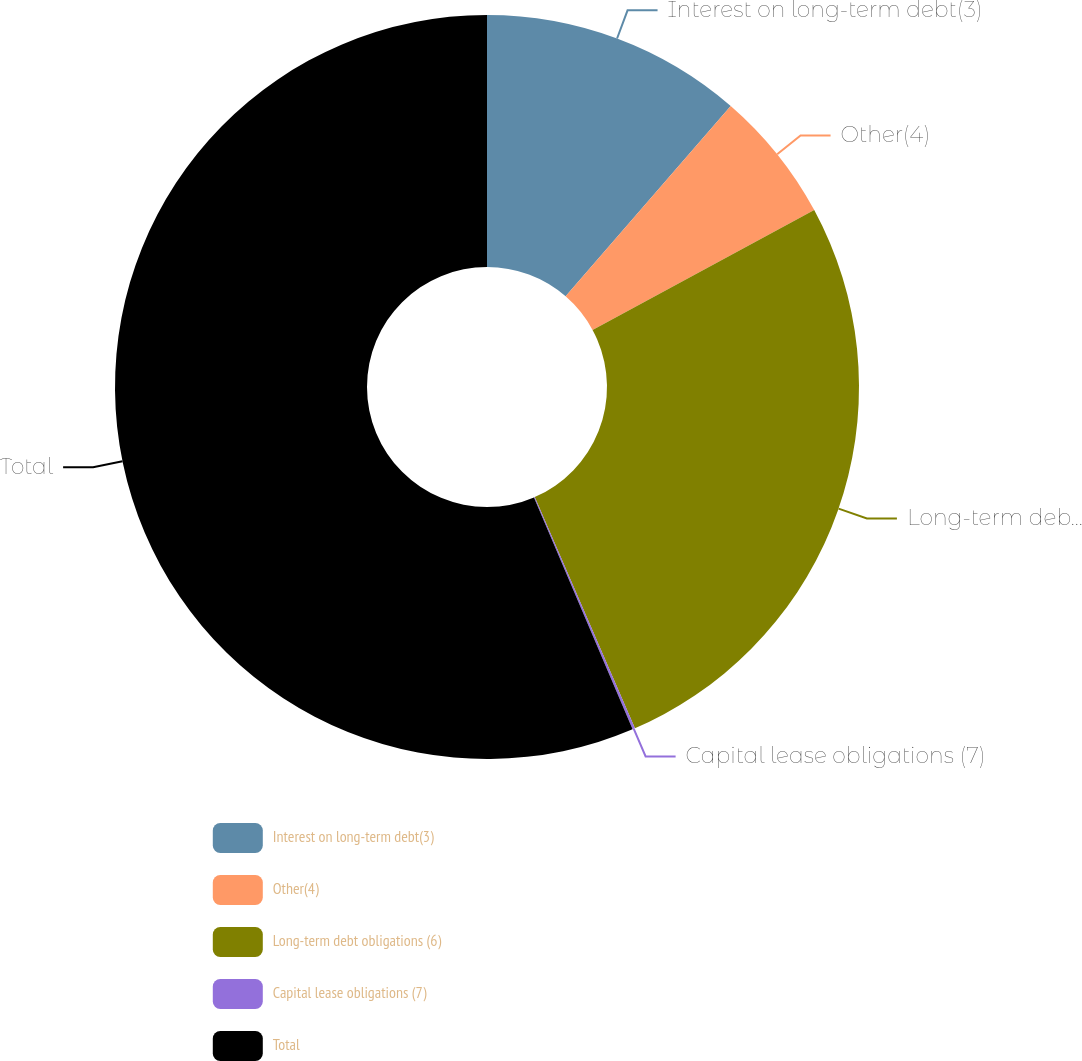<chart> <loc_0><loc_0><loc_500><loc_500><pie_chart><fcel>Interest on long-term debt(3)<fcel>Other(4)<fcel>Long-term debt obligations (6)<fcel>Capital lease obligations (7)<fcel>Total<nl><fcel>11.37%<fcel>5.74%<fcel>26.38%<fcel>0.11%<fcel>56.4%<nl></chart> 